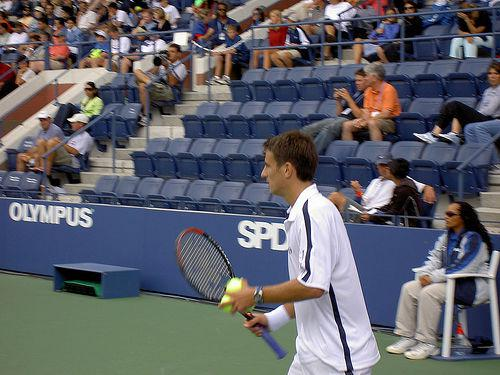Question: who is sitting in the bleachers?
Choices:
A. Coaches.
B. Photographers.
C. The fans.
D. Parents.
Answer with the letter. Answer: C Question: what color jacket does the lady in the chair wearing?
Choices:
A. Black.
B. Yellow.
C. Blue and white.
D. Green.
Answer with the letter. Answer: C Question: why is the man walking?
Choices:
A. To play soccer.
B. To play tennis.
C. To play Frisbee.
D. To go surfing.
Answer with the letter. Answer: B 